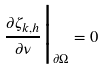Convert formula to latex. <formula><loc_0><loc_0><loc_500><loc_500>\frac { \partial \zeta _ { k , h } } { \partial \nu } \Big | _ { \partial \Omega } = 0</formula> 